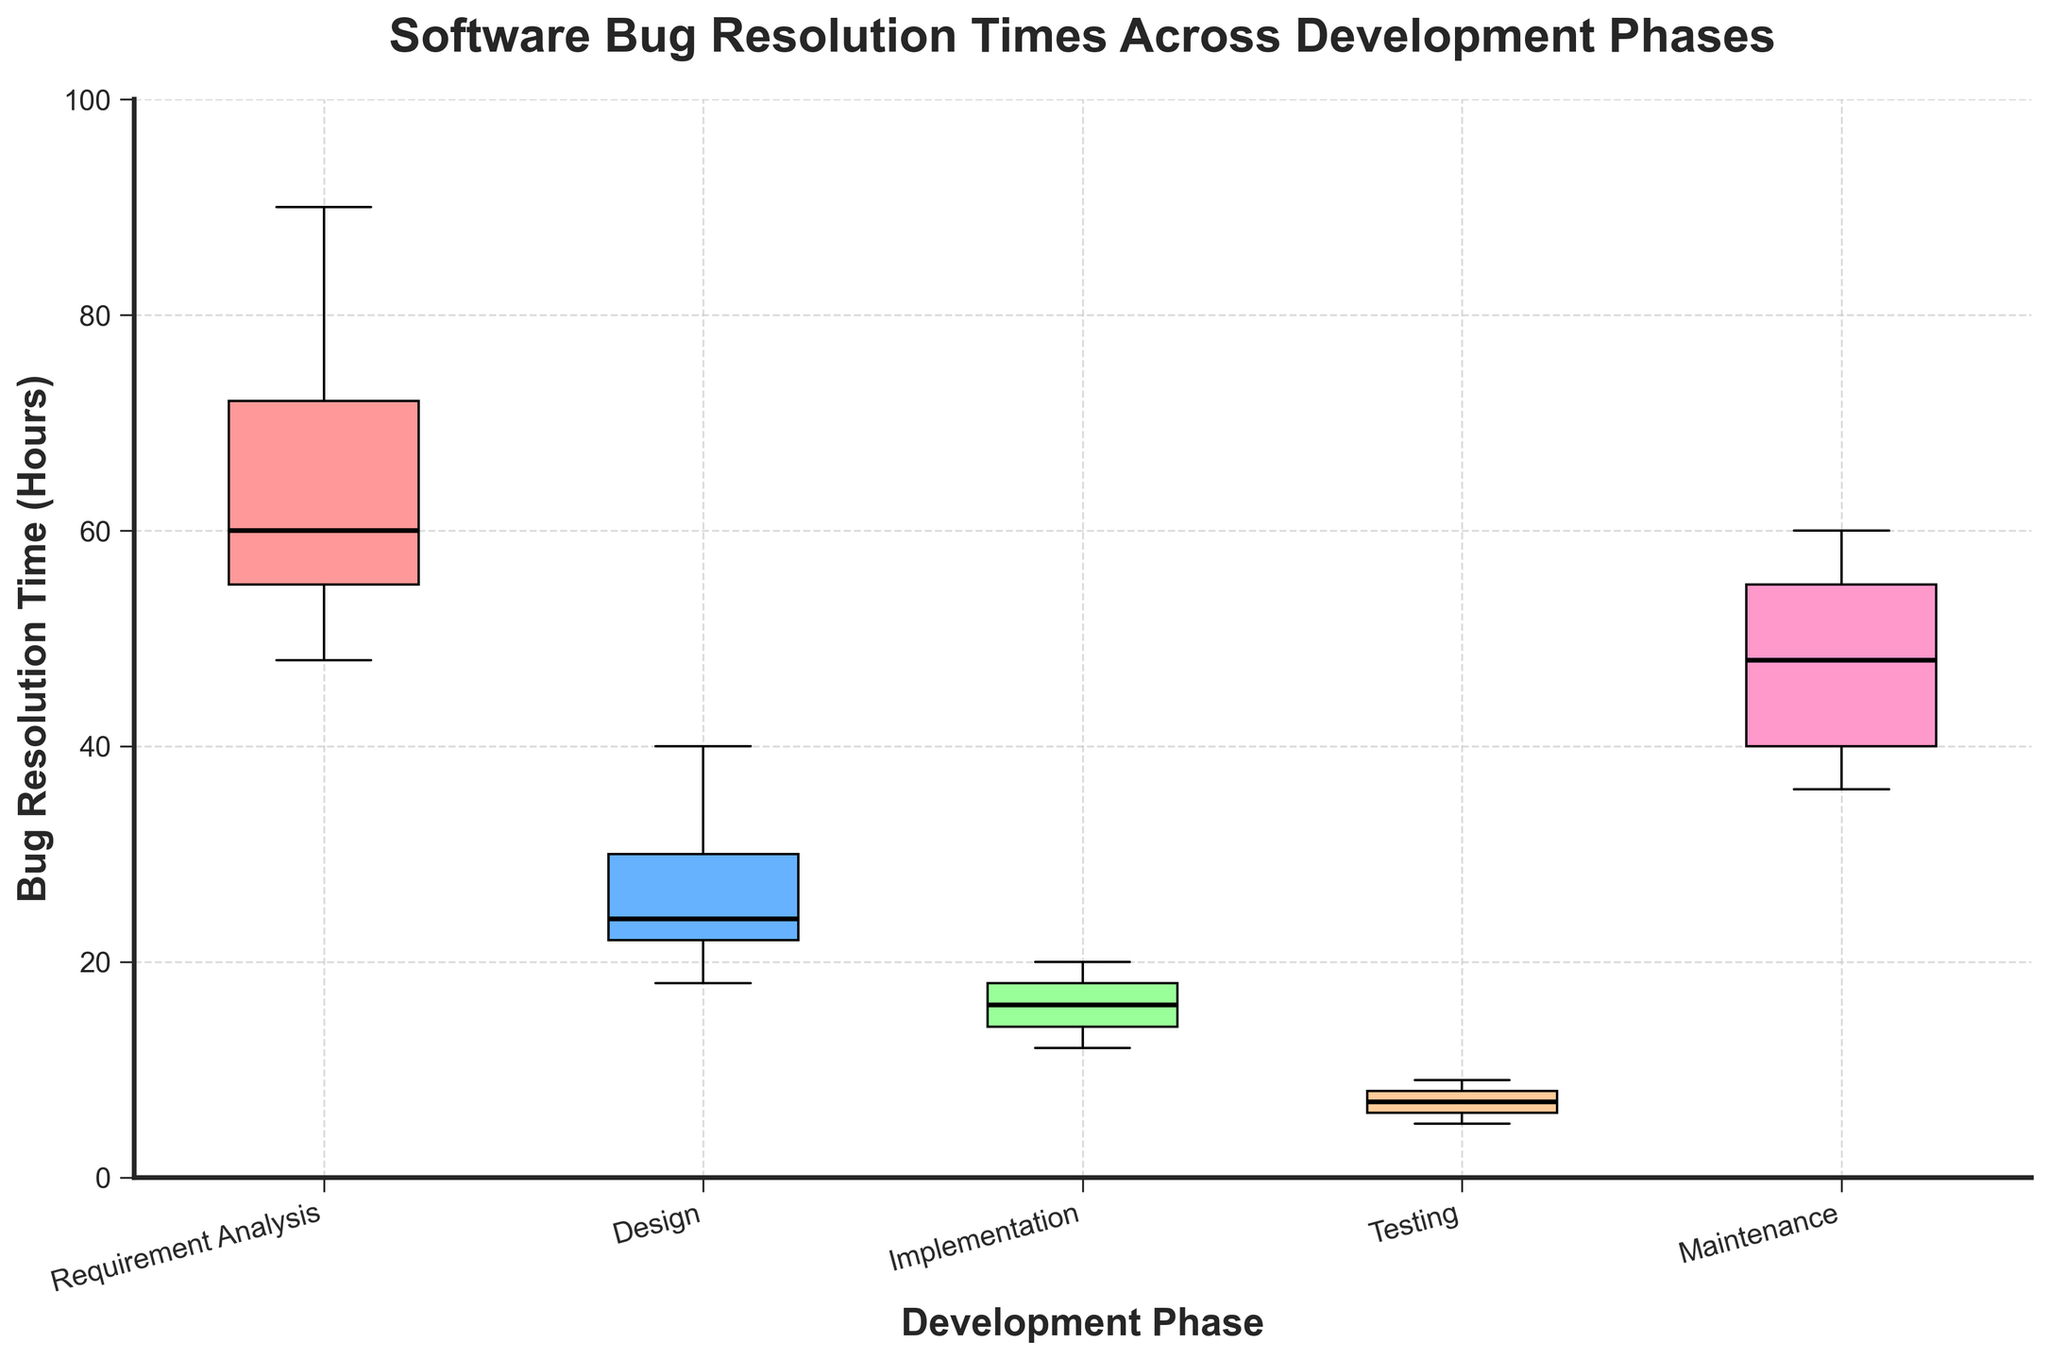What is the title of the box plot? The title of the box plot is prominently displayed at the top of the figure and reads "Software Bug Resolution Times Across Development Phases" in bold font.
Answer: Software Bug Resolution Times Across Development Phases Which development phase has the smallest median bug resolution time? By examining the black horizontal lines within the boxes, which represent the median values, we can see that the Testing phase has the smallest median bug resolution time.
Answer: Testing What is the range of bug resolution times for the Maintenance phase? The range can be determined by looking at the ends of the box and the whiskers. The minimum time is the bottom whisker and the maximum time is the top whisker. For Maintenance, it ranges from 36 to 60 hours.
Answer: 36 to 60 hours Which phase has the widest interquartile range (IQR)? The IQR is the range between the first quartile (bottom of the box) and the third quartile (top of the box). By visually assessing the height of the boxes, Requirement Analysis has the widest IQR.
Answer: Requirement Analysis Compare the median bug resolution times of Design and Implementation phases. Which one is higher? The black horizontal lines inside the boxes show the medians. The median line is higher in the Design phase than the Implementation phase, indicating that Design has a higher median bug resolution time.
Answer: Design Which phase has the most outlier points? Outliers are represented by red diamond markers outside the whiskers. By counting these markers, we can see that the Requirement Analysis phase has the most outliers.
Answer: Requirement Analysis What is the upper whisker value for the Implementation phase, and how does it compare to the upper whisker value of the Testing phase? The upper whisker is the highest line extending from the top of the box. For Implementation, it reaches 20 hours, whereas for Testing it is 9 hours. Implementation has a higher upper whisker value.
Answer: Implementation is higher What is the interquartile range (IQR) for the Design phase? The IQR is the difference between the third quartile (top of the box) and the first quartile (bottom of the box). For Design, it ranges from 22 to 30 hours, so IQR = 30 - 22 = 8 hours.
Answer: 8 hours How does the spread of bug resolution times in Requirement Analysis compare to that in Testing? By comparing the lengths of the boxes and the whiskers, Requirement Analysis has a much larger spread of bug resolution times compared to Testing. The Requirement Analysis box and whiskers cover a more extensive range.
Answer: Requirement Analysis has a larger spread 